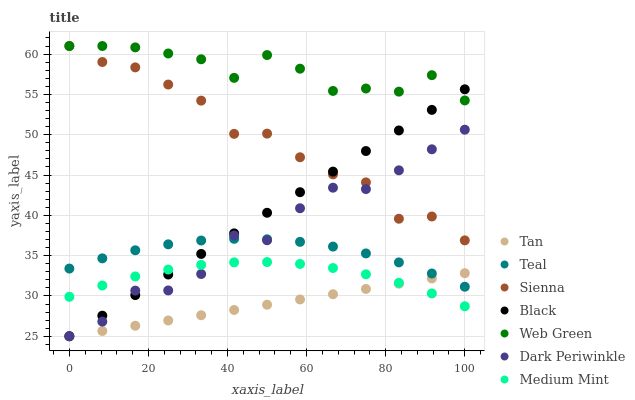Does Tan have the minimum area under the curve?
Answer yes or no. Yes. Does Web Green have the maximum area under the curve?
Answer yes or no. Yes. Does Sienna have the minimum area under the curve?
Answer yes or no. No. Does Sienna have the maximum area under the curve?
Answer yes or no. No. Is Black the smoothest?
Answer yes or no. Yes. Is Dark Periwinkle the roughest?
Answer yes or no. Yes. Is Web Green the smoothest?
Answer yes or no. No. Is Web Green the roughest?
Answer yes or no. No. Does Black have the lowest value?
Answer yes or no. Yes. Does Sienna have the lowest value?
Answer yes or no. No. Does Sienna have the highest value?
Answer yes or no. Yes. Does Black have the highest value?
Answer yes or no. No. Is Tan less than Web Green?
Answer yes or no. Yes. Is Sienna greater than Medium Mint?
Answer yes or no. Yes. Does Dark Periwinkle intersect Tan?
Answer yes or no. Yes. Is Dark Periwinkle less than Tan?
Answer yes or no. No. Is Dark Periwinkle greater than Tan?
Answer yes or no. No. Does Tan intersect Web Green?
Answer yes or no. No. 